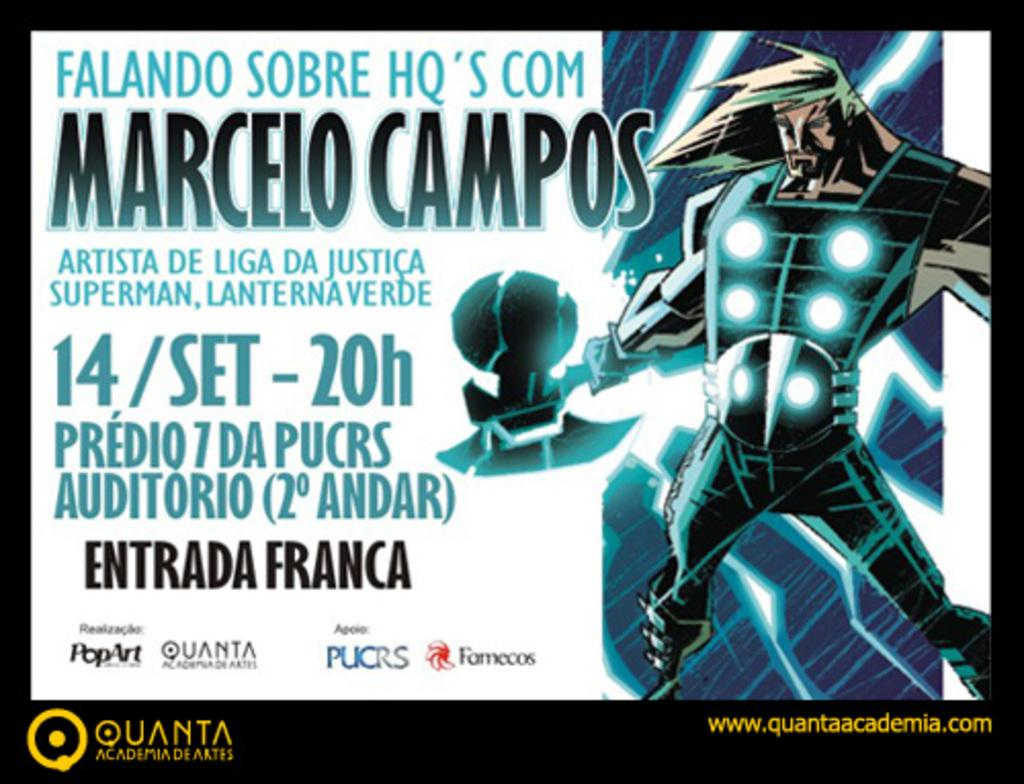<image>
Relay a brief, clear account of the picture shown. A Quanta logo can be seen with and ad for an event. 